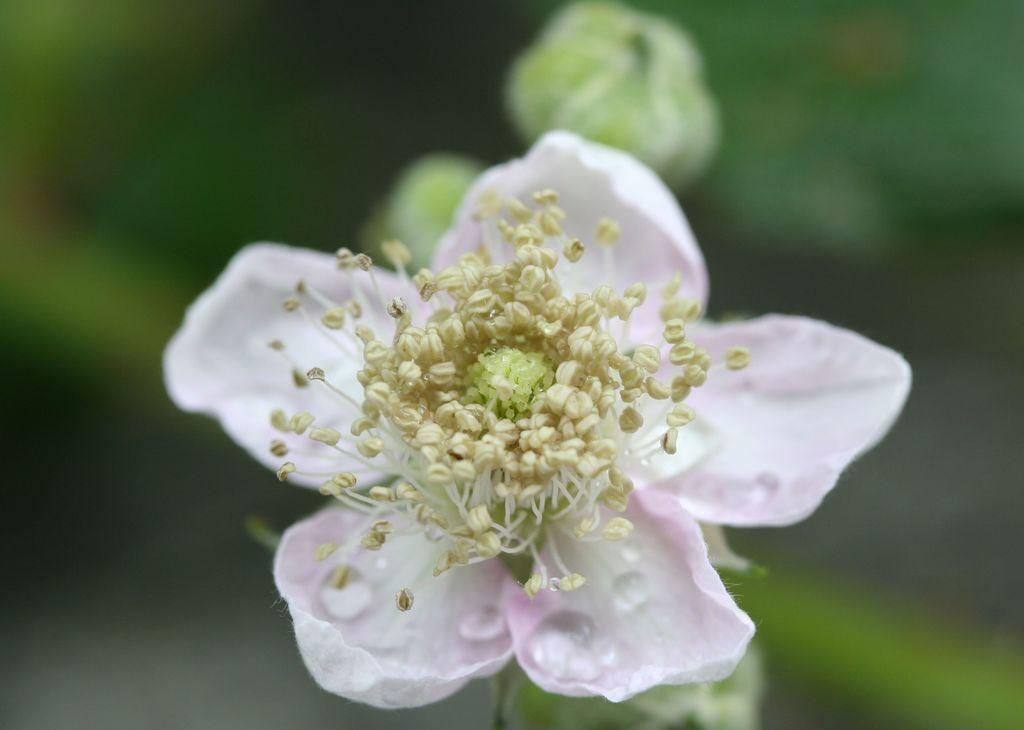What is the main subject of the image? There is a flower in the image. Can you describe the colors of the flower? The flower has pink and yellow colors. How would you describe the background of the image? The background of the image is blurred. What type of pest can be seen crawling on the flower in the image? There is no pest present on the flower in the image. How does the flower provide a thrilling experience for the viewer? The image does not convey any information about the viewer's experience, so it cannot be determined if the flower provides a thrilling experience. 